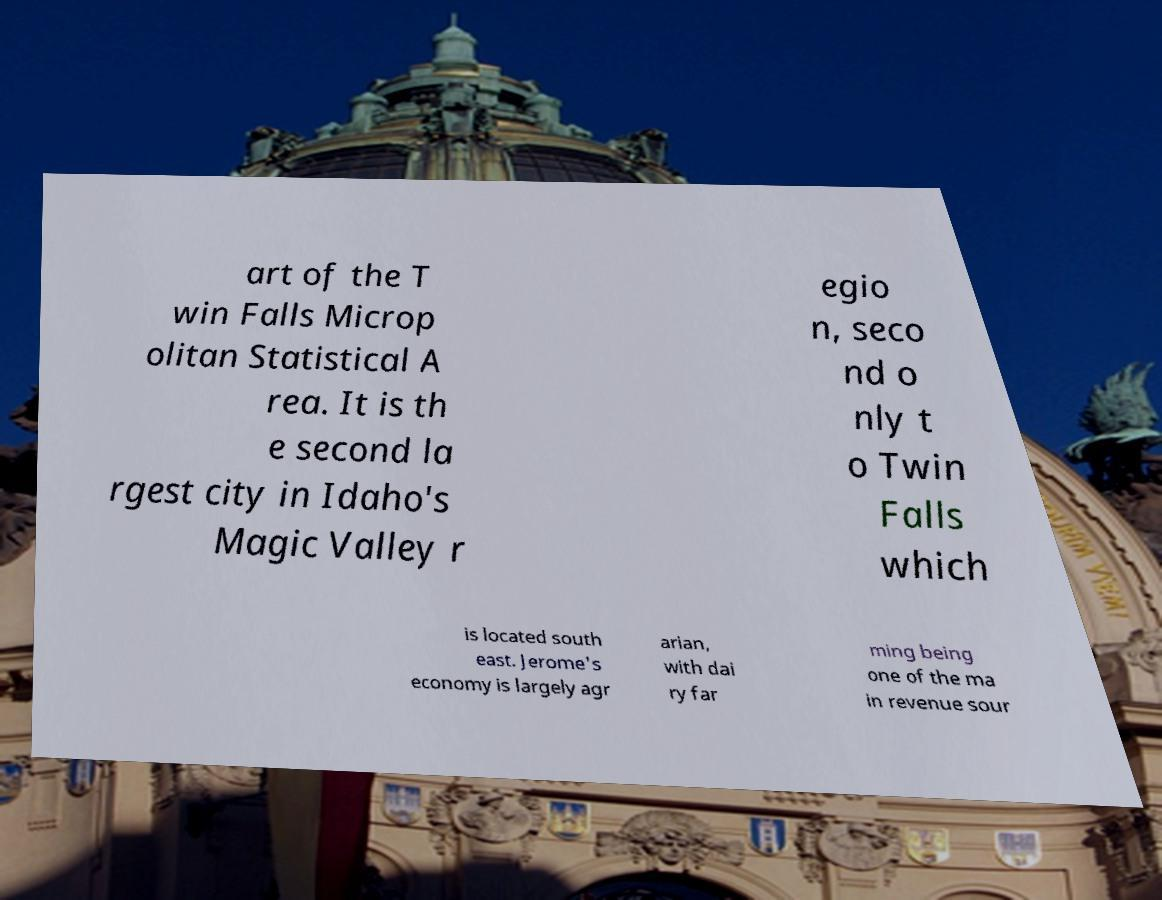What messages or text are displayed in this image? I need them in a readable, typed format. art of the T win Falls Microp olitan Statistical A rea. It is th e second la rgest city in Idaho's Magic Valley r egio n, seco nd o nly t o Twin Falls which is located south east. Jerome's economy is largely agr arian, with dai ry far ming being one of the ma in revenue sour 